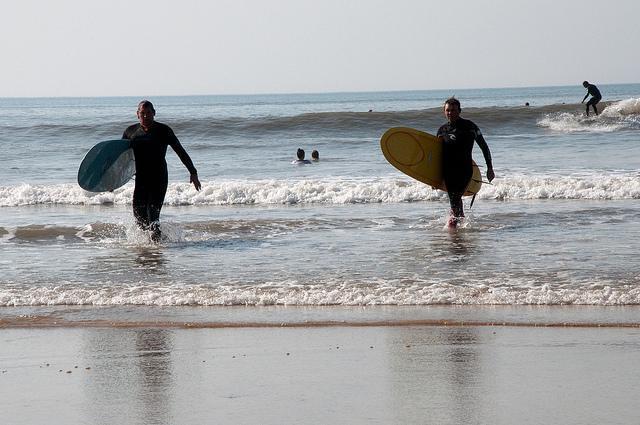How many people are in the photo?
Give a very brief answer. 2. How many surfboards are in the photo?
Give a very brief answer. 2. How many giraffes are there?
Give a very brief answer. 0. 